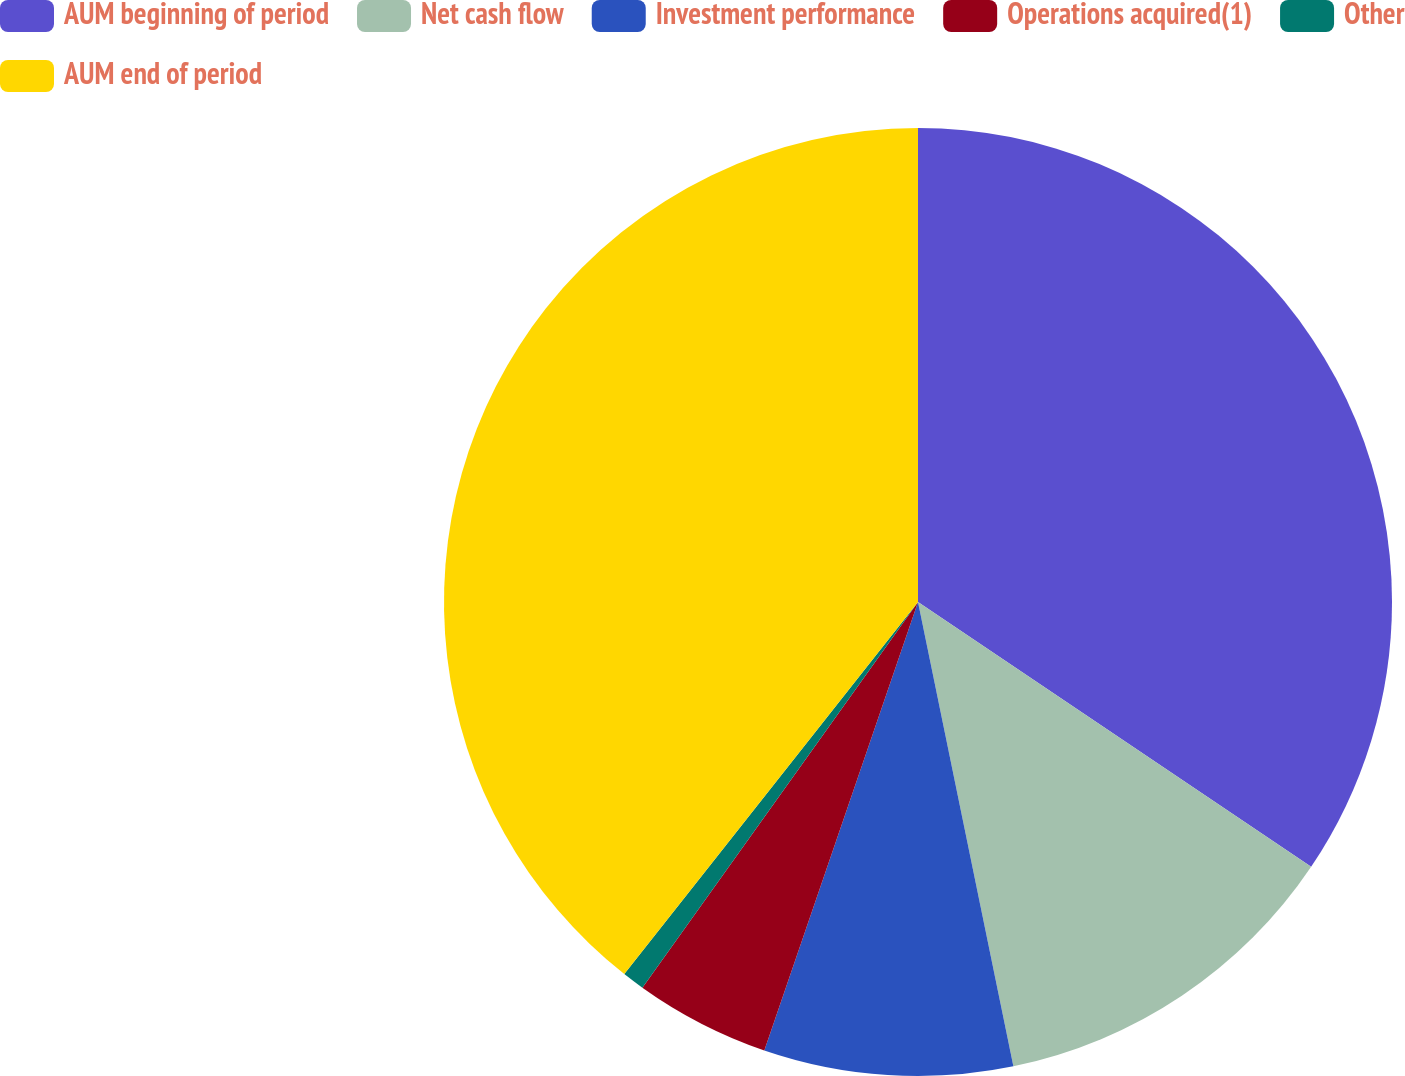<chart> <loc_0><loc_0><loc_500><loc_500><pie_chart><fcel>AUM beginning of period<fcel>Net cash flow<fcel>Investment performance<fcel>Operations acquired(1)<fcel>Other<fcel>AUM end of period<nl><fcel>34.43%<fcel>12.34%<fcel>8.48%<fcel>4.62%<fcel>0.76%<fcel>39.36%<nl></chart> 